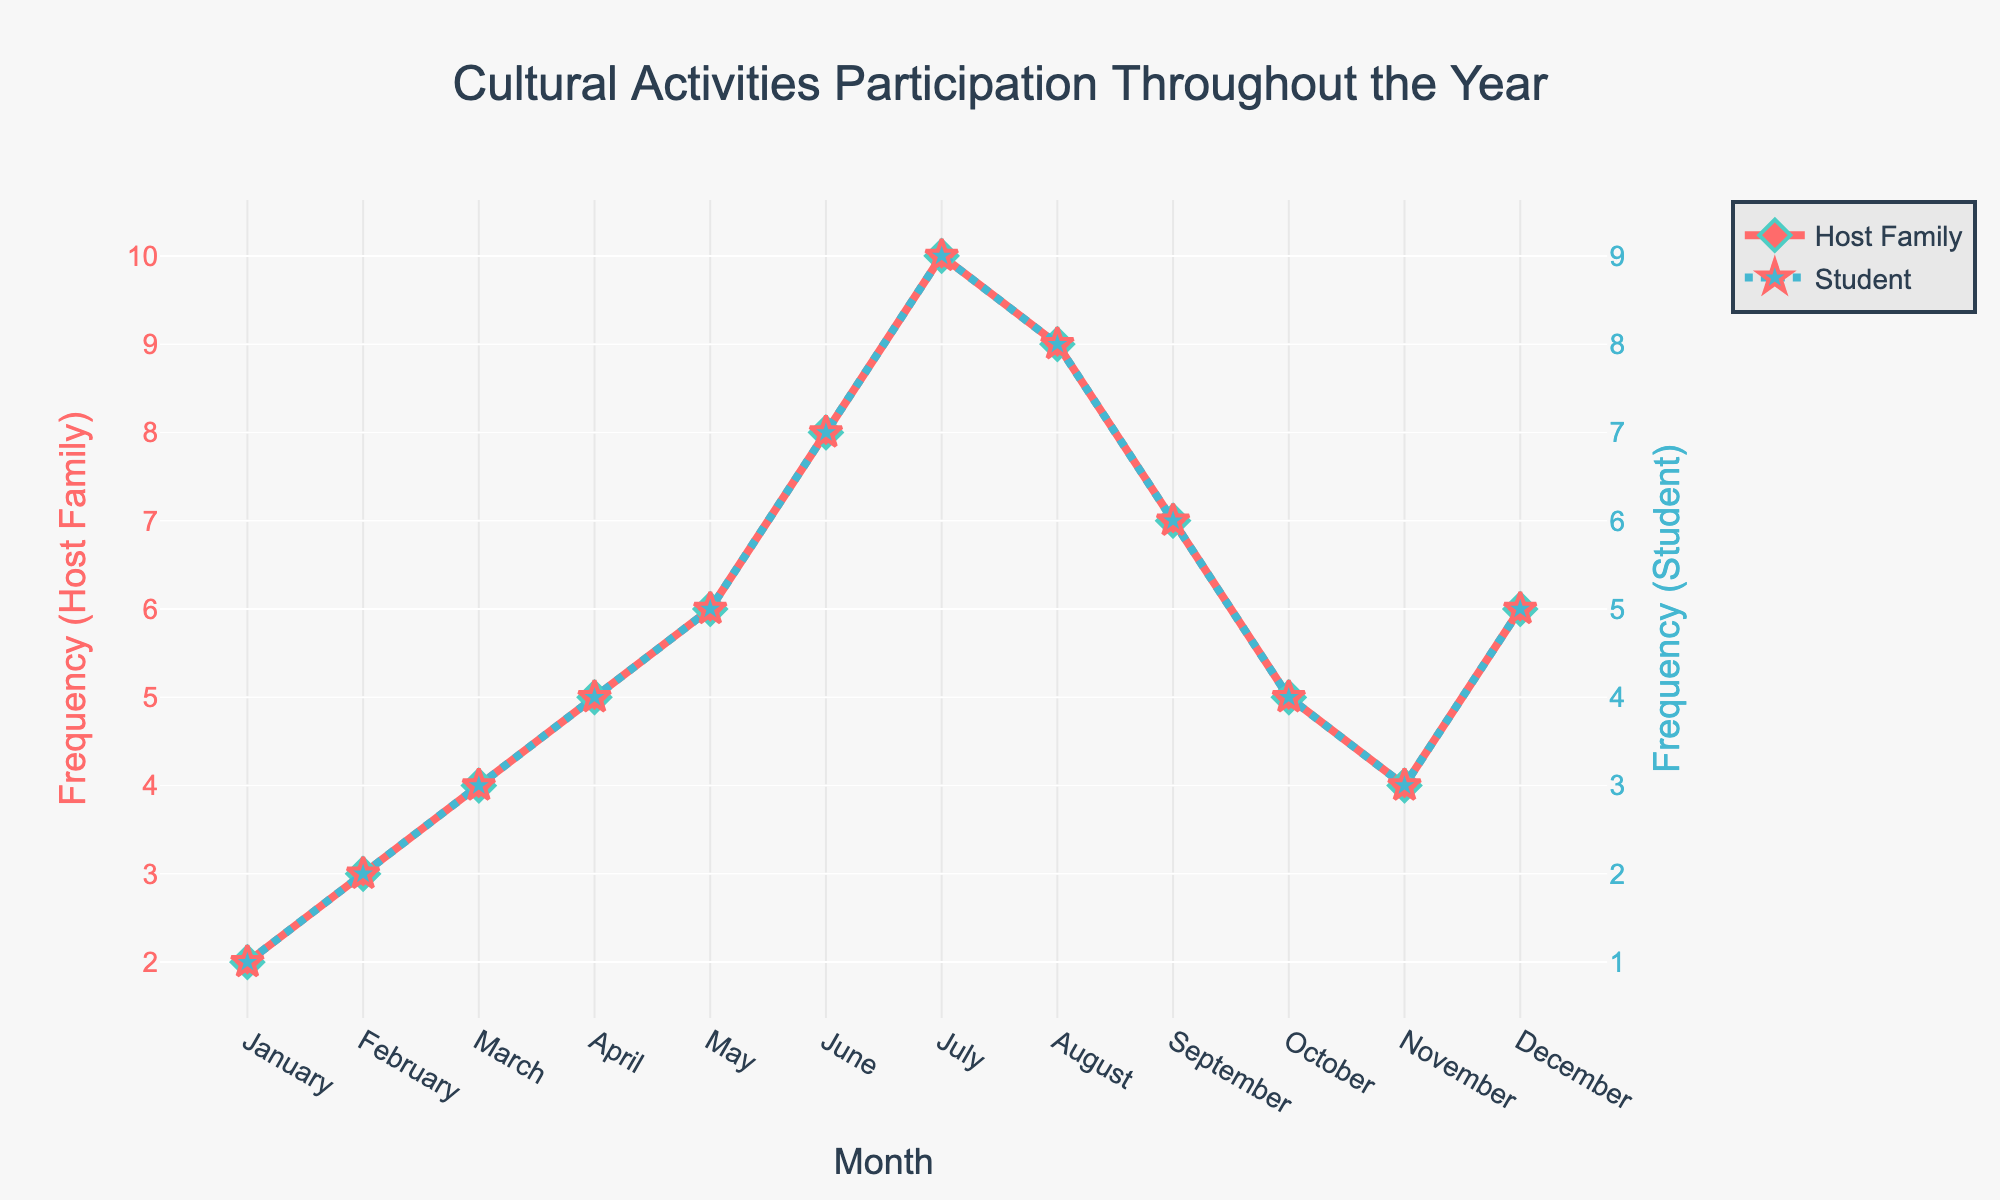What is the highest frequency of cultural activities participated in by host families, and in which month does it occur? The figure shows a peak in the line for host families in July, reaching the highest value.
Answer: July, 10 During which month did the students’ participation in cultural activities equal the host families' participation? The lines for both host families and students intersect at two points, which are in May and December, where the frequencies are equal.
Answer: May, December What is the difference in the number of cultural activities between host families and students in June? Find the values for June: Host Family is 8 and Student is 7. Calculate the difference: 8 - 7 = 1.
Answer: 1 Which month shows the smallest gap in participation frequency between host families and students? Check the differences for each month between Host Family and Student, the smallest difference is 1, which occurs in June and July.
Answer: June, July How does the trend in cultural activity participation change for host families from May to November? The host families’ participation increases from May (6) to a peak in July (10), then decreases steadily to November (4).
Answer: Peaks in July, then decreases On average, how many cultural activities per month do students participate in? To find the average, sum all monthly values for students (1+2+3+4+5+7+9+8+6+4+3+5=57) and divide by the number of months (12). The average is 57/12 = 4.75.
Answer: 4.75 Which month shows a more significant increase in cultural activities for host families than students compared to the previous month? Between January to February, the host families’ participation increases from 2 to 3 (+1), and students’ increases from 1 to 2 (+1). Between February to March, both increase by the same amount. Between March to April, both increase equally again. Between April to May, both increase equally again. The only month where the host family shows a significantly larger increase than students is from May to June (6 to 8 for host families, 5 to 7 for students). Both increase by 2. Therefore, there is no significant single month where host families' increase is more than students. Generally, no single month shows a more significant change for only one group. Only multiples months with equal increases are indicated.
Answer: None In which month does the participation frequency for host families drop the most compared to the previous month? The sharpest decline occurs from July (10) to August (9), resulting in a drop of 1.
Answer: From July to August What is the combined total of cultural activities for host families and students in April? Add the April values: Host Family (5) + Student (4) = 9.
Answer: 9 